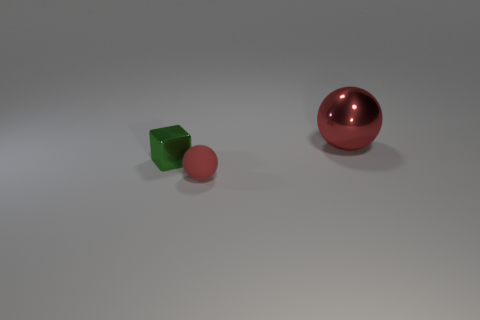If these objects were illuminated by a single light source, from which direction would the light be coming based on the shadows? Based on the shadows being cast by the objects, it appears that the light source is positioned above and to the right of the objects. The shadows extend to the left, indicating light coming from the opposite direction. 